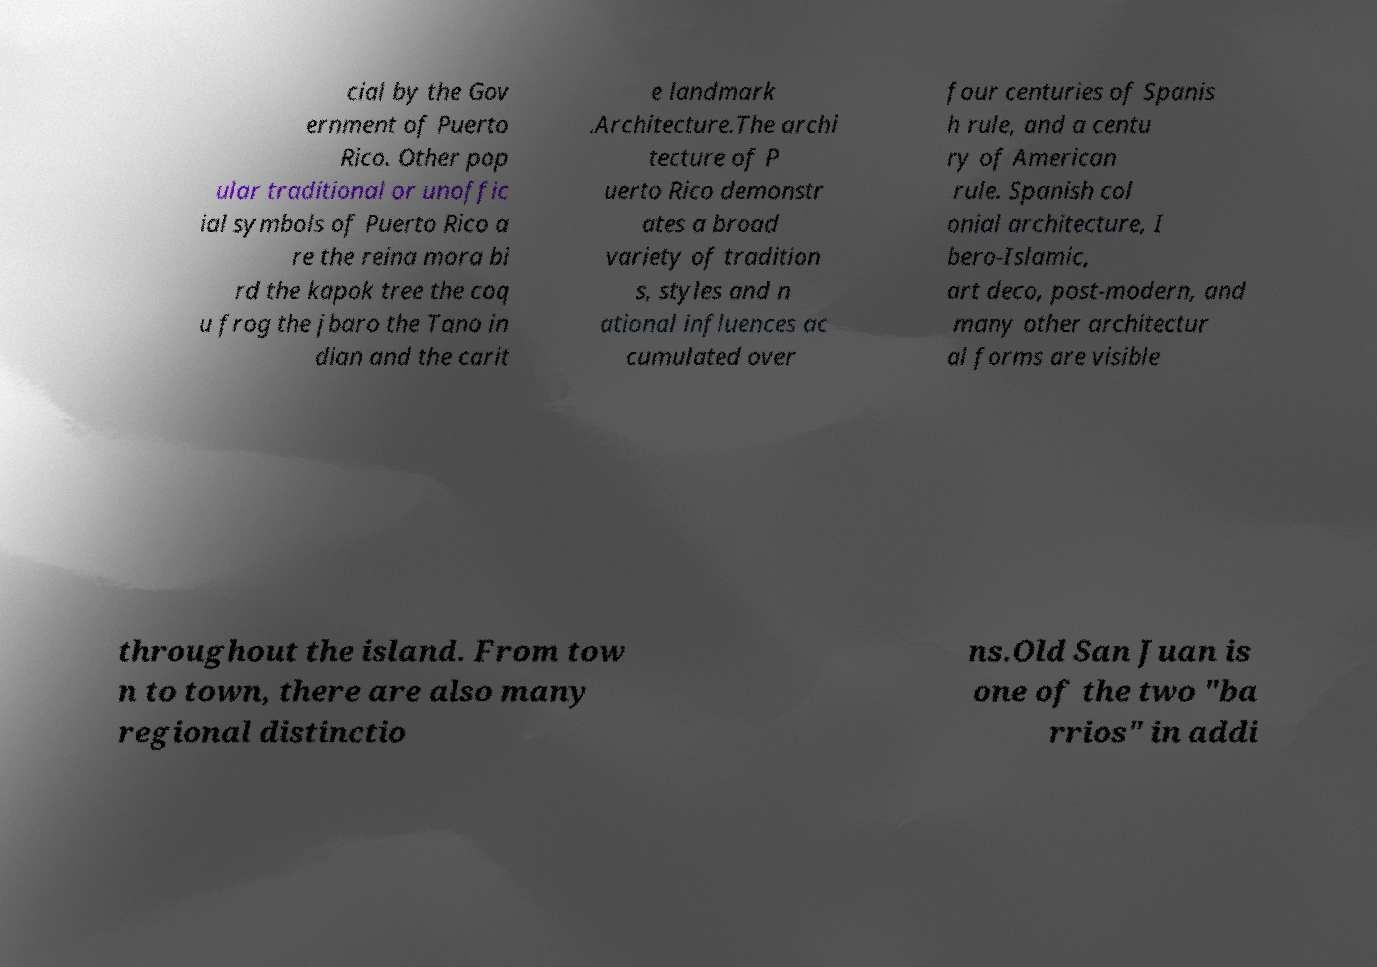For documentation purposes, I need the text within this image transcribed. Could you provide that? cial by the Gov ernment of Puerto Rico. Other pop ular traditional or unoffic ial symbols of Puerto Rico a re the reina mora bi rd the kapok tree the coq u frog the jbaro the Tano in dian and the carit e landmark .Architecture.The archi tecture of P uerto Rico demonstr ates a broad variety of tradition s, styles and n ational influences ac cumulated over four centuries of Spanis h rule, and a centu ry of American rule. Spanish col onial architecture, I bero-Islamic, art deco, post-modern, and many other architectur al forms are visible throughout the island. From tow n to town, there are also many regional distinctio ns.Old San Juan is one of the two "ba rrios" in addi 